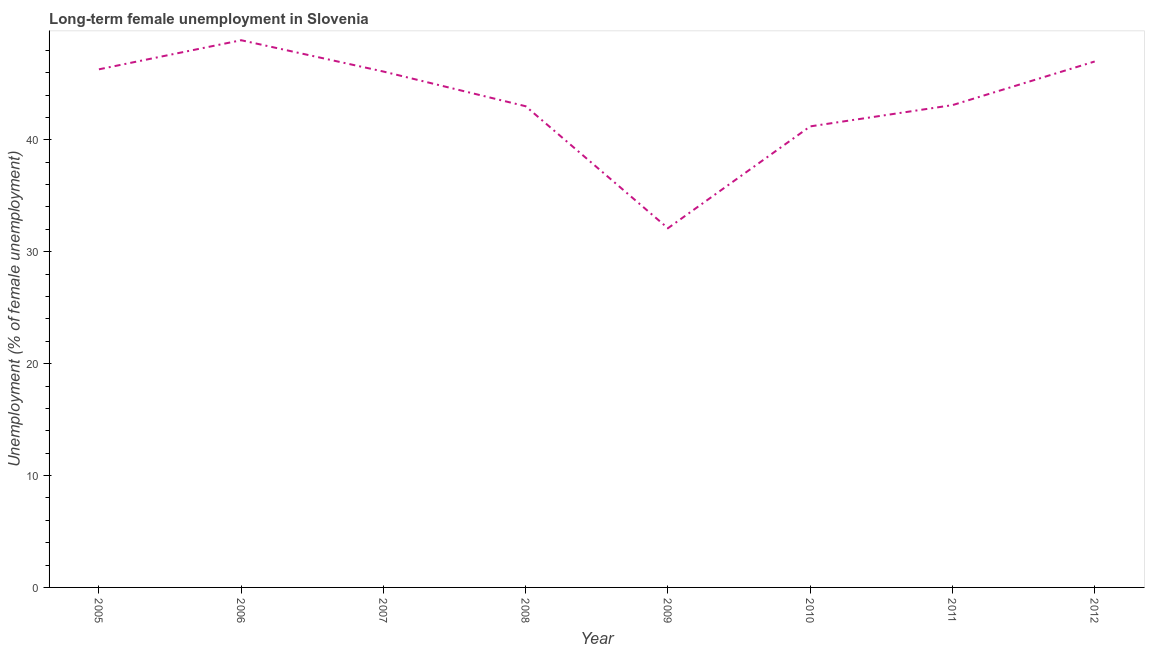What is the long-term female unemployment in 2006?
Offer a very short reply. 48.9. Across all years, what is the maximum long-term female unemployment?
Your response must be concise. 48.9. Across all years, what is the minimum long-term female unemployment?
Provide a succinct answer. 32.1. In which year was the long-term female unemployment maximum?
Ensure brevity in your answer.  2006. What is the sum of the long-term female unemployment?
Give a very brief answer. 347.7. What is the difference between the long-term female unemployment in 2007 and 2008?
Your answer should be very brief. 3.1. What is the average long-term female unemployment per year?
Your answer should be compact. 43.46. What is the median long-term female unemployment?
Your response must be concise. 44.6. Do a majority of the years between 2010 and 2008 (inclusive) have long-term female unemployment greater than 34 %?
Your response must be concise. No. What is the ratio of the long-term female unemployment in 2005 to that in 2012?
Your answer should be very brief. 0.99. Is the difference between the long-term female unemployment in 2007 and 2009 greater than the difference between any two years?
Offer a very short reply. No. What is the difference between the highest and the second highest long-term female unemployment?
Provide a short and direct response. 1.9. Is the sum of the long-term female unemployment in 2006 and 2009 greater than the maximum long-term female unemployment across all years?
Ensure brevity in your answer.  Yes. What is the difference between the highest and the lowest long-term female unemployment?
Ensure brevity in your answer.  16.8. In how many years, is the long-term female unemployment greater than the average long-term female unemployment taken over all years?
Offer a very short reply. 4. Does the long-term female unemployment monotonically increase over the years?
Ensure brevity in your answer.  No. How many lines are there?
Give a very brief answer. 1. What is the difference between two consecutive major ticks on the Y-axis?
Provide a succinct answer. 10. Does the graph contain any zero values?
Offer a very short reply. No. What is the title of the graph?
Give a very brief answer. Long-term female unemployment in Slovenia. What is the label or title of the X-axis?
Ensure brevity in your answer.  Year. What is the label or title of the Y-axis?
Give a very brief answer. Unemployment (% of female unemployment). What is the Unemployment (% of female unemployment) of 2005?
Keep it short and to the point. 46.3. What is the Unemployment (% of female unemployment) of 2006?
Offer a terse response. 48.9. What is the Unemployment (% of female unemployment) in 2007?
Give a very brief answer. 46.1. What is the Unemployment (% of female unemployment) of 2009?
Give a very brief answer. 32.1. What is the Unemployment (% of female unemployment) in 2010?
Your answer should be compact. 41.2. What is the Unemployment (% of female unemployment) of 2011?
Give a very brief answer. 43.1. What is the difference between the Unemployment (% of female unemployment) in 2005 and 2006?
Keep it short and to the point. -2.6. What is the difference between the Unemployment (% of female unemployment) in 2005 and 2010?
Your answer should be very brief. 5.1. What is the difference between the Unemployment (% of female unemployment) in 2006 and 2007?
Your answer should be very brief. 2.8. What is the difference between the Unemployment (% of female unemployment) in 2006 and 2008?
Keep it short and to the point. 5.9. What is the difference between the Unemployment (% of female unemployment) in 2006 and 2011?
Offer a very short reply. 5.8. What is the difference between the Unemployment (% of female unemployment) in 2007 and 2010?
Give a very brief answer. 4.9. What is the difference between the Unemployment (% of female unemployment) in 2008 and 2010?
Give a very brief answer. 1.8. What is the difference between the Unemployment (% of female unemployment) in 2008 and 2012?
Ensure brevity in your answer.  -4. What is the difference between the Unemployment (% of female unemployment) in 2009 and 2011?
Provide a short and direct response. -11. What is the difference between the Unemployment (% of female unemployment) in 2009 and 2012?
Your answer should be very brief. -14.9. What is the difference between the Unemployment (% of female unemployment) in 2010 and 2011?
Provide a succinct answer. -1.9. What is the difference between the Unemployment (% of female unemployment) in 2010 and 2012?
Provide a succinct answer. -5.8. What is the ratio of the Unemployment (% of female unemployment) in 2005 to that in 2006?
Your response must be concise. 0.95. What is the ratio of the Unemployment (% of female unemployment) in 2005 to that in 2008?
Give a very brief answer. 1.08. What is the ratio of the Unemployment (% of female unemployment) in 2005 to that in 2009?
Make the answer very short. 1.44. What is the ratio of the Unemployment (% of female unemployment) in 2005 to that in 2010?
Keep it short and to the point. 1.12. What is the ratio of the Unemployment (% of female unemployment) in 2005 to that in 2011?
Offer a terse response. 1.07. What is the ratio of the Unemployment (% of female unemployment) in 2006 to that in 2007?
Provide a succinct answer. 1.06. What is the ratio of the Unemployment (% of female unemployment) in 2006 to that in 2008?
Provide a succinct answer. 1.14. What is the ratio of the Unemployment (% of female unemployment) in 2006 to that in 2009?
Your answer should be very brief. 1.52. What is the ratio of the Unemployment (% of female unemployment) in 2006 to that in 2010?
Offer a very short reply. 1.19. What is the ratio of the Unemployment (% of female unemployment) in 2006 to that in 2011?
Offer a very short reply. 1.14. What is the ratio of the Unemployment (% of female unemployment) in 2007 to that in 2008?
Make the answer very short. 1.07. What is the ratio of the Unemployment (% of female unemployment) in 2007 to that in 2009?
Keep it short and to the point. 1.44. What is the ratio of the Unemployment (% of female unemployment) in 2007 to that in 2010?
Your answer should be very brief. 1.12. What is the ratio of the Unemployment (% of female unemployment) in 2007 to that in 2011?
Your answer should be very brief. 1.07. What is the ratio of the Unemployment (% of female unemployment) in 2008 to that in 2009?
Offer a terse response. 1.34. What is the ratio of the Unemployment (% of female unemployment) in 2008 to that in 2010?
Provide a short and direct response. 1.04. What is the ratio of the Unemployment (% of female unemployment) in 2008 to that in 2012?
Provide a succinct answer. 0.92. What is the ratio of the Unemployment (% of female unemployment) in 2009 to that in 2010?
Offer a terse response. 0.78. What is the ratio of the Unemployment (% of female unemployment) in 2009 to that in 2011?
Your answer should be compact. 0.74. What is the ratio of the Unemployment (% of female unemployment) in 2009 to that in 2012?
Your answer should be very brief. 0.68. What is the ratio of the Unemployment (% of female unemployment) in 2010 to that in 2011?
Offer a terse response. 0.96. What is the ratio of the Unemployment (% of female unemployment) in 2010 to that in 2012?
Provide a succinct answer. 0.88. What is the ratio of the Unemployment (% of female unemployment) in 2011 to that in 2012?
Keep it short and to the point. 0.92. 